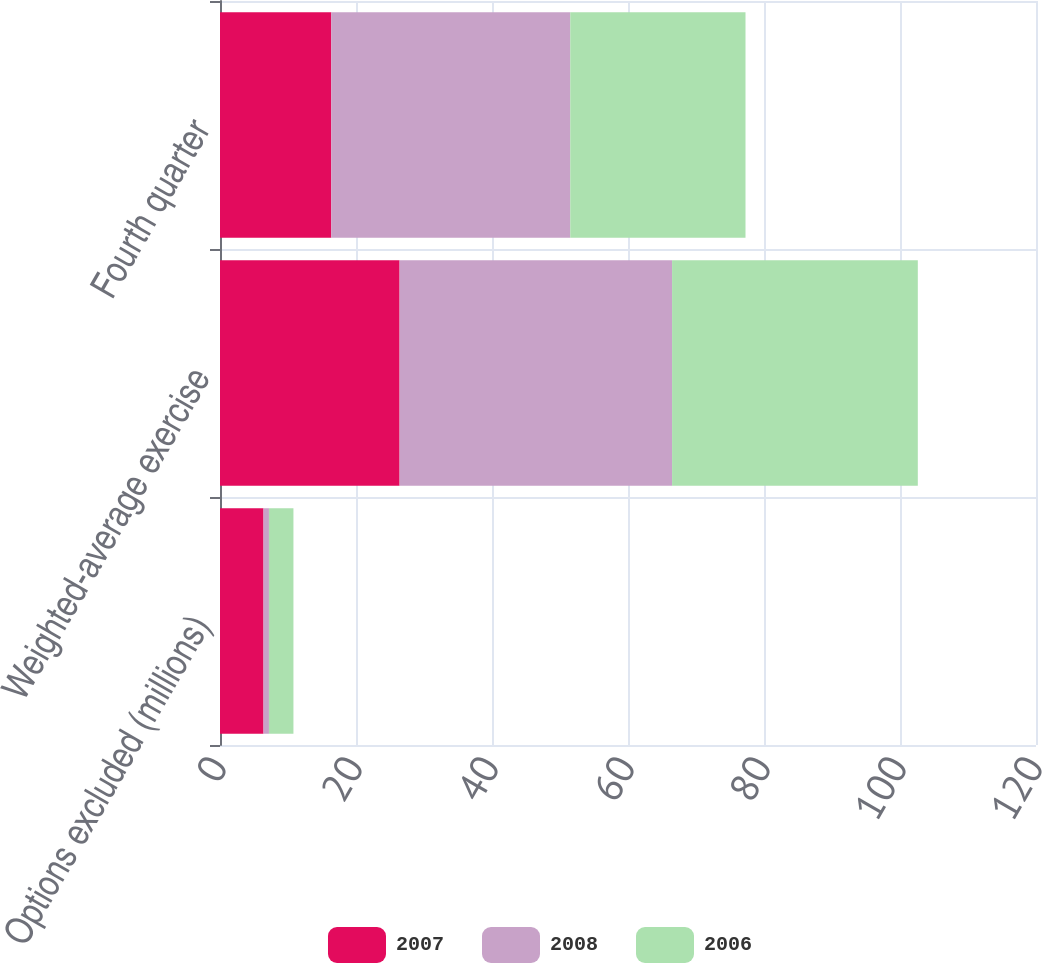Convert chart to OTSL. <chart><loc_0><loc_0><loc_500><loc_500><stacked_bar_chart><ecel><fcel>Options excluded (millions)<fcel>Weighted-average exercise<fcel>Fourth quarter<nl><fcel>2007<fcel>6.4<fcel>26.41<fcel>16.37<nl><fcel>2008<fcel>0.8<fcel>40.07<fcel>35.14<nl><fcel>2006<fcel>3.6<fcel>36.14<fcel>25.77<nl></chart> 